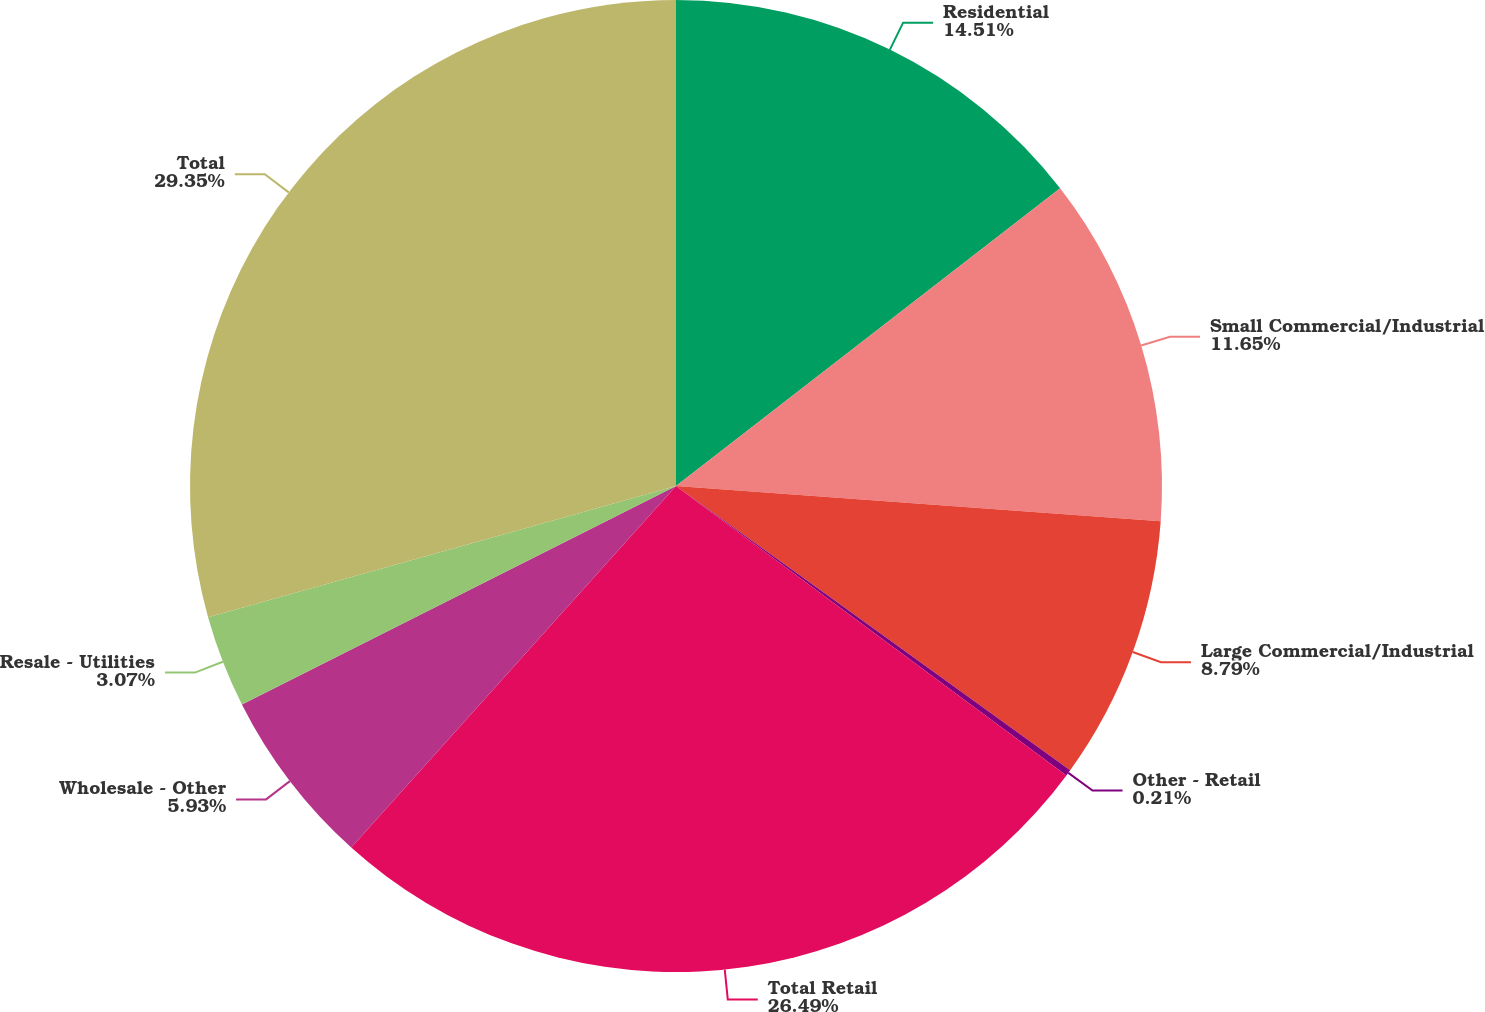Convert chart to OTSL. <chart><loc_0><loc_0><loc_500><loc_500><pie_chart><fcel>Residential<fcel>Small Commercial/Industrial<fcel>Large Commercial/Industrial<fcel>Other - Retail<fcel>Total Retail<fcel>Wholesale - Other<fcel>Resale - Utilities<fcel>Total<nl><fcel>14.51%<fcel>11.65%<fcel>8.79%<fcel>0.21%<fcel>26.5%<fcel>5.93%<fcel>3.07%<fcel>29.36%<nl></chart> 